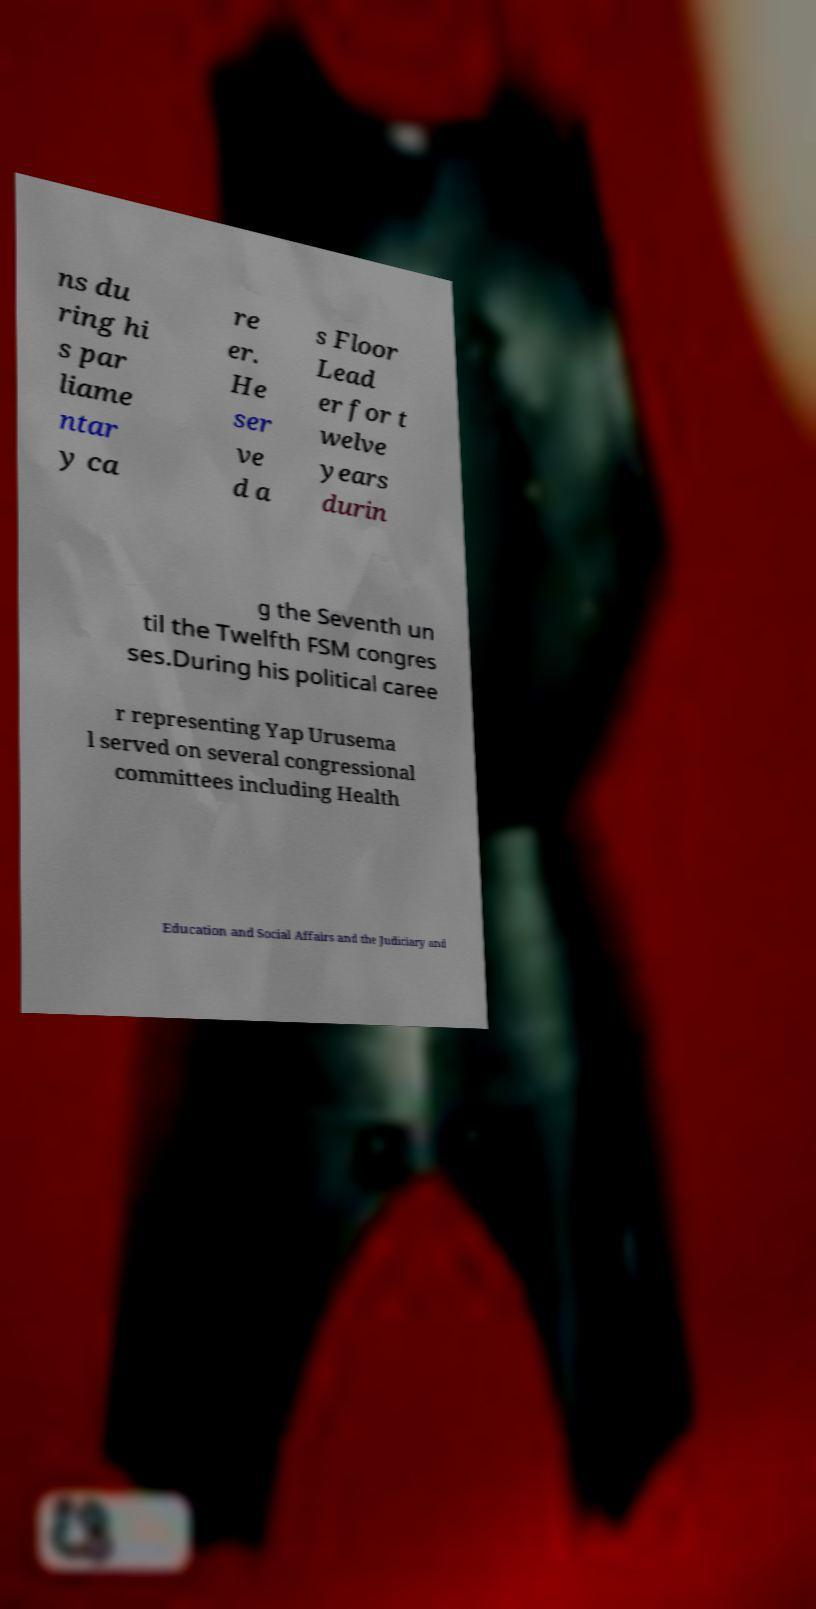Please identify and transcribe the text found in this image. ns du ring hi s par liame ntar y ca re er. He ser ve d a s Floor Lead er for t welve years durin g the Seventh un til the Twelfth FSM congres ses.During his political caree r representing Yap Urusema l served on several congressional committees including Health Education and Social Affairs and the Judiciary and 